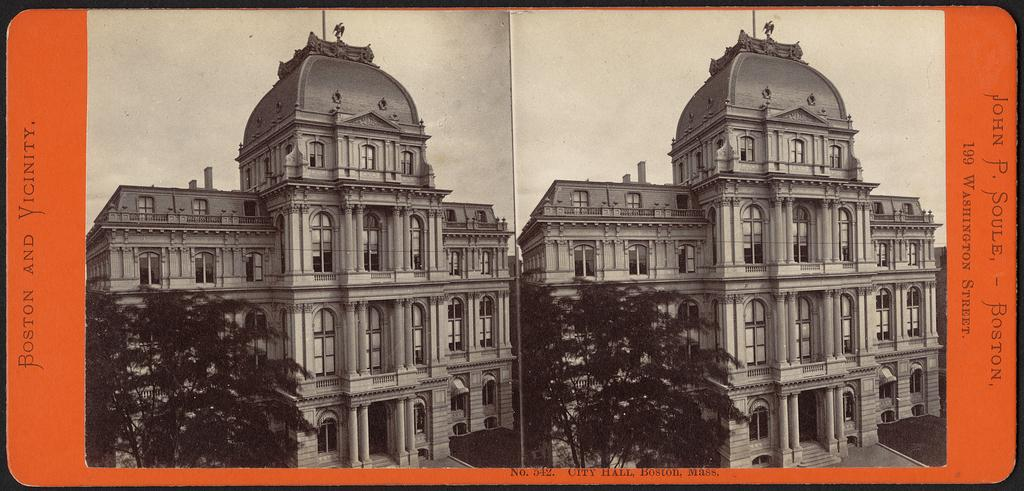What is featured in the image? There is a poster in the image. What is shown on the poster? The poster depicts old buildings. Are there any other elements in the image besides the poster? Yes, trees are present near the old buildings. How would you describe the weather in the image? The sky is cloudy in the image. What type of pin can be seen holding the poster to the wall in the image? There is no pin visible in the image holding the poster to the wall. What type of attraction is depicted in the image? The image does not depict any attractions; it features a poster with old buildings and trees. 